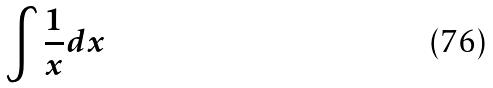<formula> <loc_0><loc_0><loc_500><loc_500>\int \frac { 1 } { x } d x</formula> 